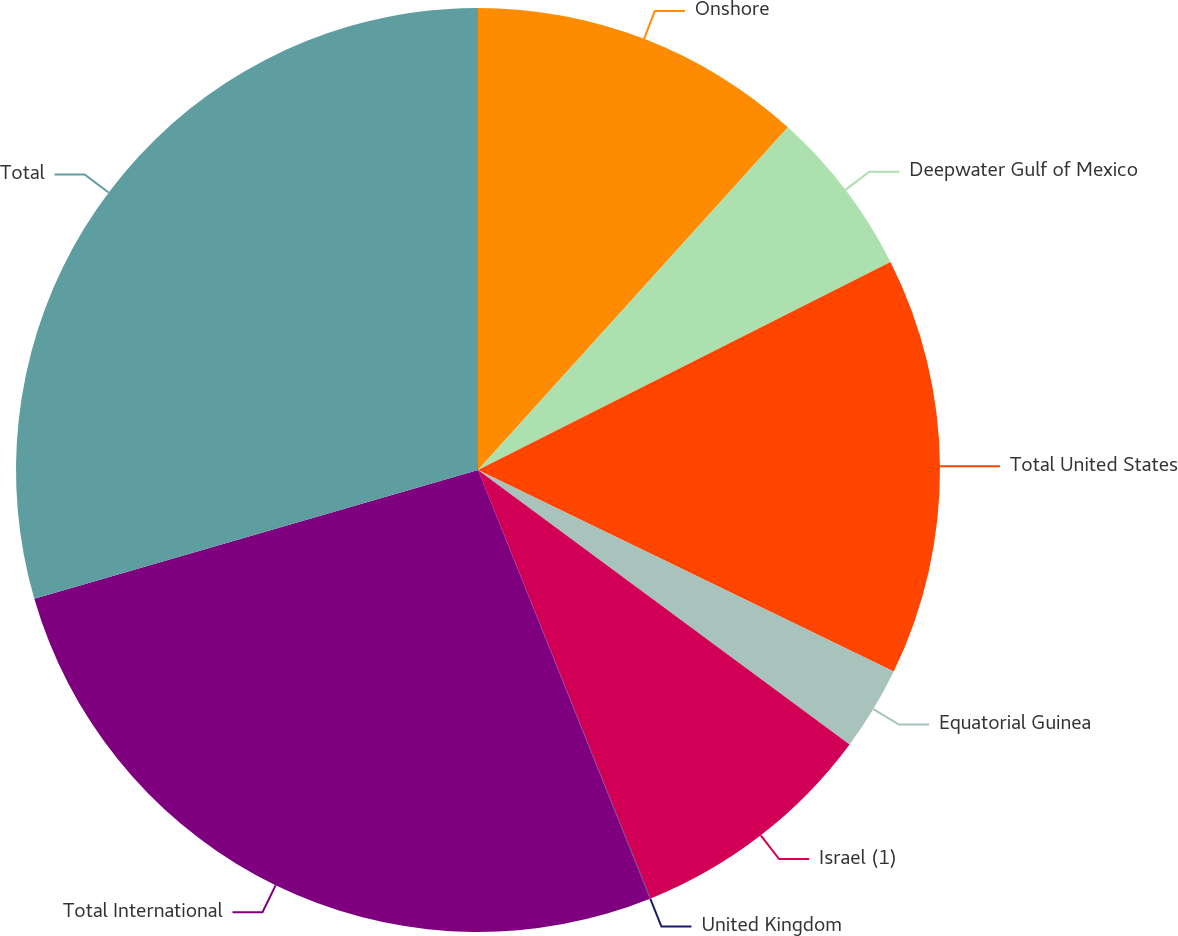<chart> <loc_0><loc_0><loc_500><loc_500><pie_chart><fcel>Onshore<fcel>Deepwater Gulf of Mexico<fcel>Total United States<fcel>Equatorial Guinea<fcel>Israel (1)<fcel>United Kingdom<fcel>Total International<fcel>Total<nl><fcel>11.7%<fcel>5.86%<fcel>14.62%<fcel>2.94%<fcel>8.78%<fcel>0.02%<fcel>26.57%<fcel>29.49%<nl></chart> 